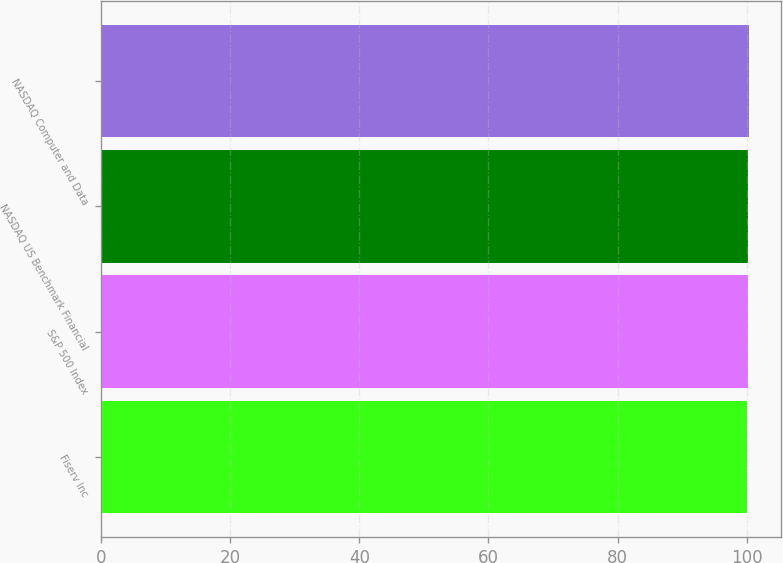Convert chart to OTSL. <chart><loc_0><loc_0><loc_500><loc_500><bar_chart><fcel>Fiserv Inc<fcel>S&P 500 Index<fcel>NASDAQ US Benchmark Financial<fcel>NASDAQ Computer and Data<nl><fcel>100<fcel>100.1<fcel>100.2<fcel>100.3<nl></chart> 